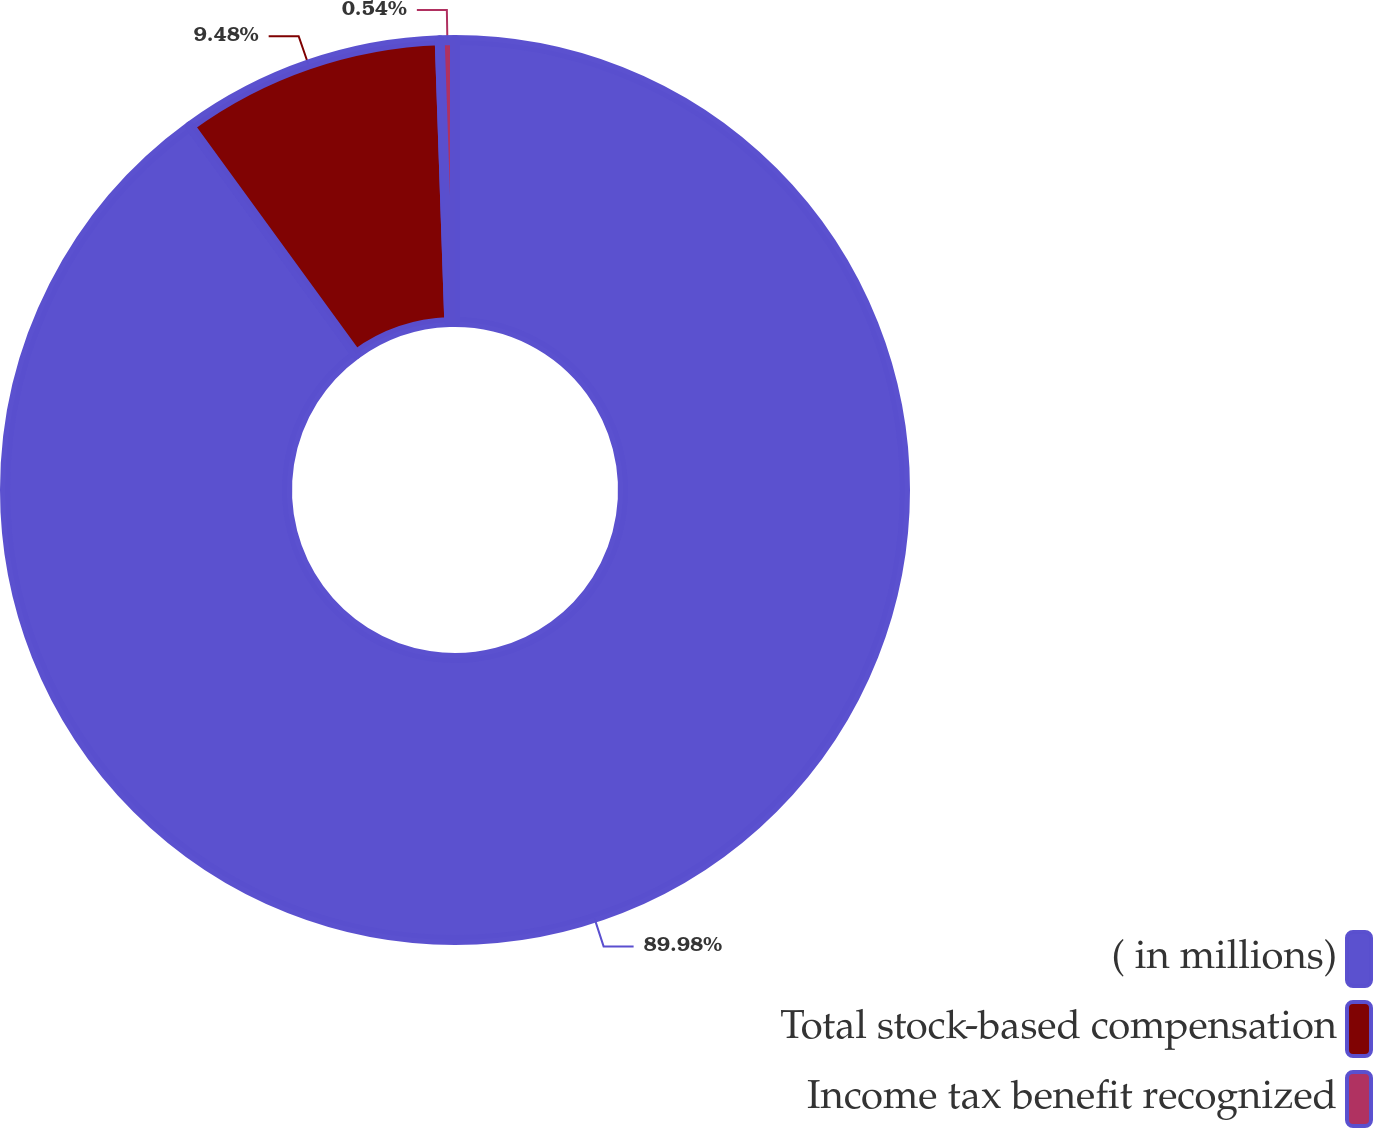<chart> <loc_0><loc_0><loc_500><loc_500><pie_chart><fcel>( in millions)<fcel>Total stock-based compensation<fcel>Income tax benefit recognized<nl><fcel>89.98%<fcel>9.48%<fcel>0.54%<nl></chart> 